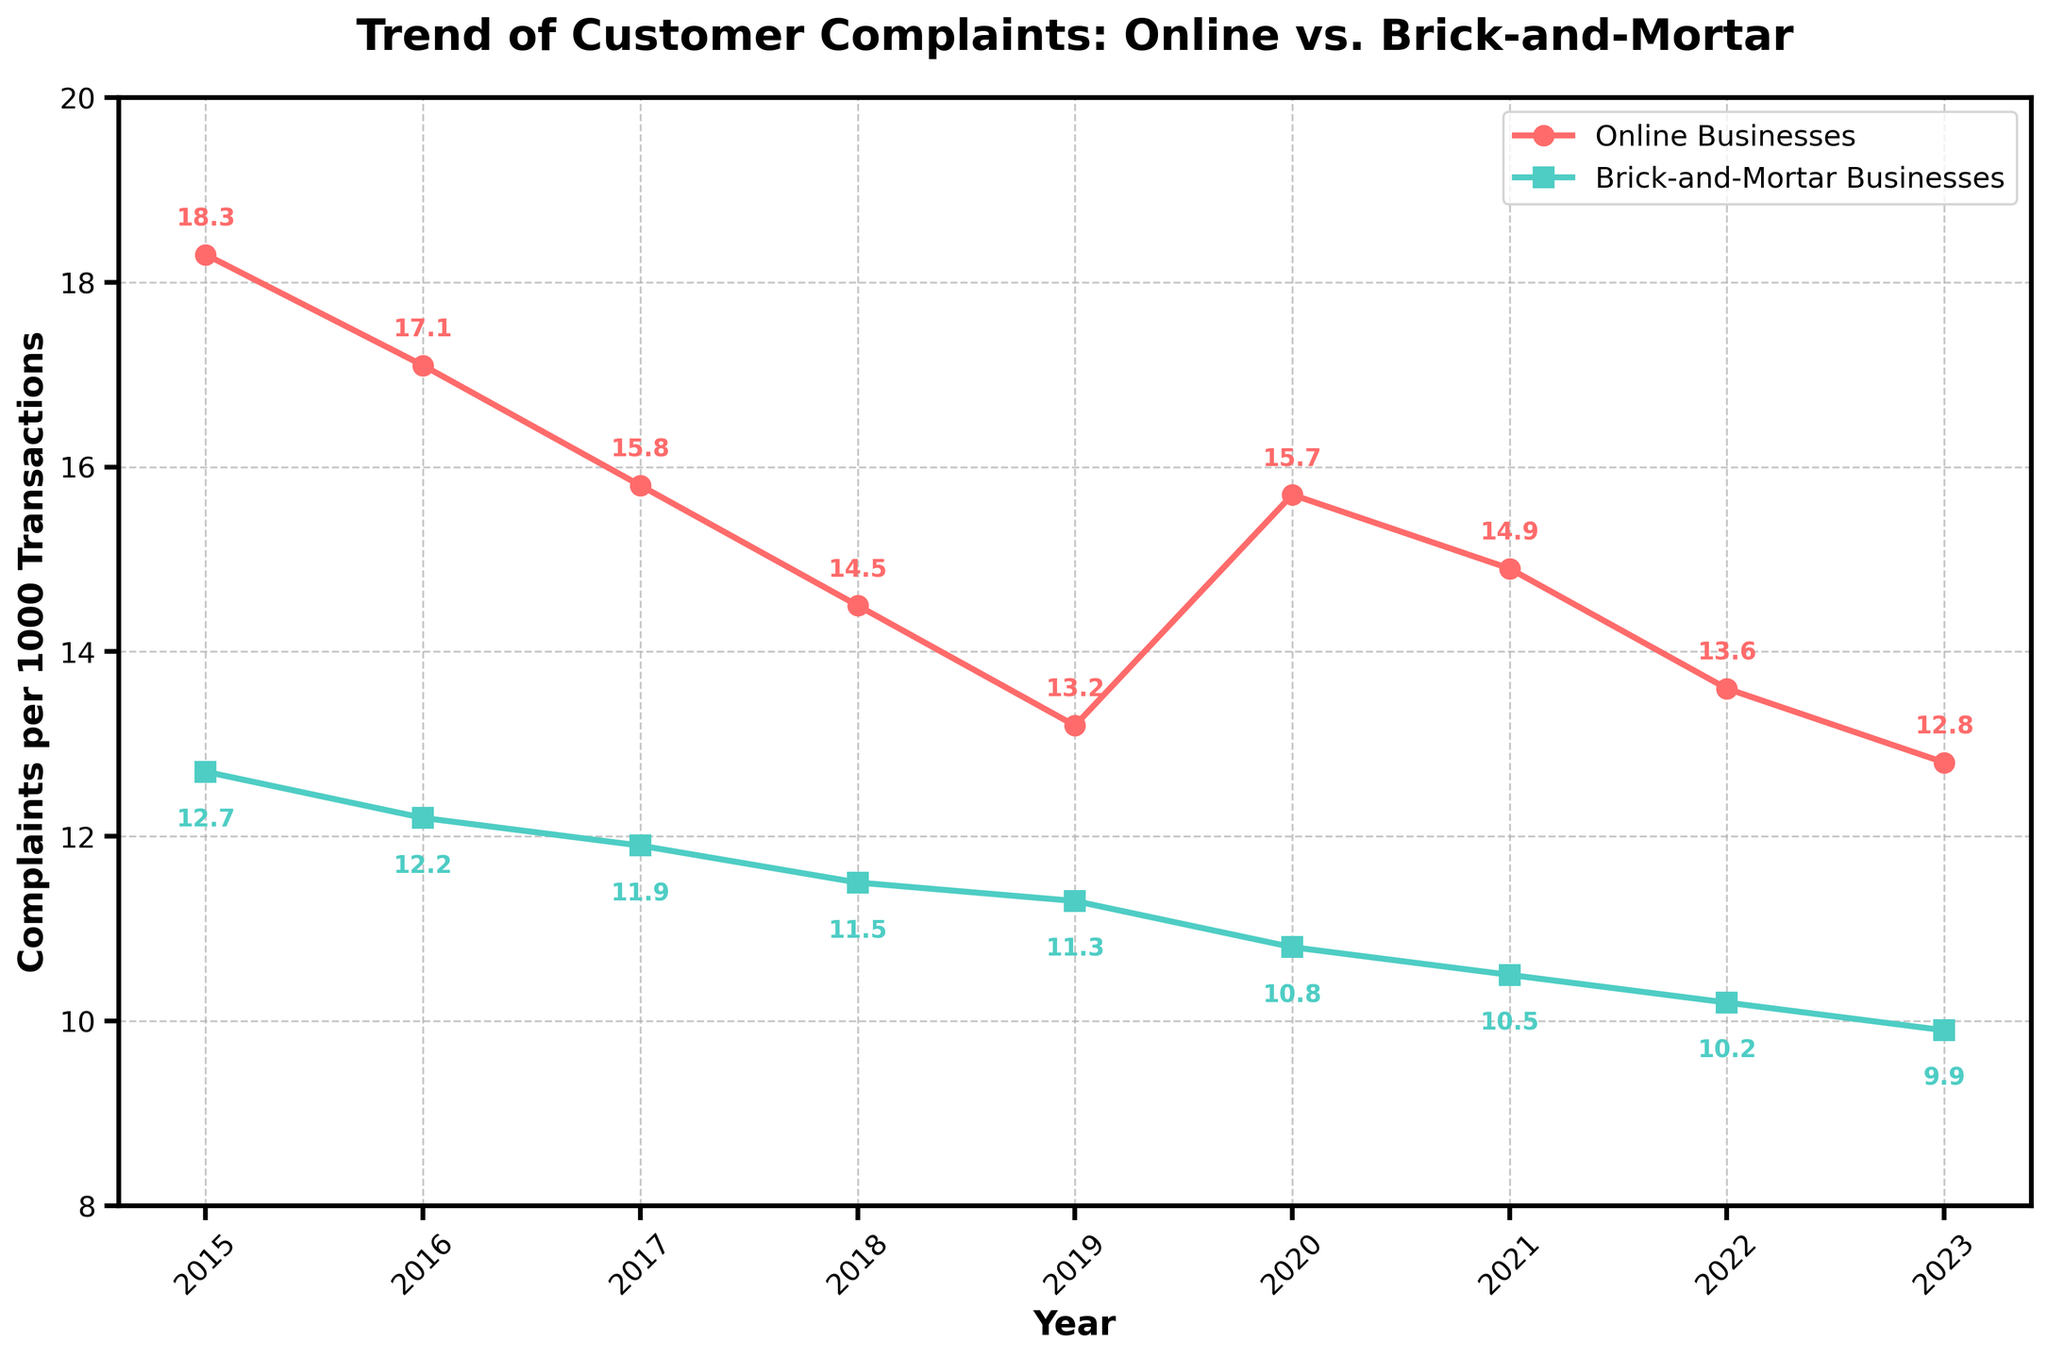What's the general trend of customer complaints for both online and brick-and-mortar businesses from 2015 to 2023? Both online and brick-and-mortar businesses show a general decline in customer complaints per 1000 transactions from 2015 to 2023. For online businesses, the complaints drop from 18.3 in 2015 to 12.8 in 2023. For brick-and-mortar businesses, the complaints decrease from 12.7 in 2015 to 9.9 in 2023.
Answer: Decline What marked change occurred in the complaint rates for online businesses between 2019 and 2020? Observation shows that the complaint rate for online businesses increased from 13.2 in 2019 to 15.7 in 2020, a jump of 2.5 complaints per 1000 transactions.
Answer: Increase of 2.5 Which year shows the highest customer complaint rate for brick-and-mortar businesses, and what is the value? The visually highest data point on the line for brick-and-mortar businesses occurs in 2015, with a complaint rate of 12.7 per 1000 transactions.
Answer: 2015, 12.7 complaints per 1000 transactions Between 2016 and 2017, which type of business (online or brick-and-mortar) showed a steeper decline in customer complaint rates? For online businesses, the complaint rate declined from 17.1 to 15.8, a decrease of 1.3. For brick-and-mortar businesses, the decline was from 12.2 to 11.9, a decrease of 0.3. The steeper decline was for online businesses (1.3).
Answer: Online businesses On average, how many complaints per 1000 transactions did online businesses receive from 2015 to 2023? To find the average, sum the values from each year and then divide by the number of years. 
(18.3 + 17.1 + 15.8 + 14.5 + 13.2 + 15.7 + 14.9 + 13.6 + 12.8) / 9 ≈ 15.5
Answer: 15.5 Compare the rates in customer complaints between online and brick-and-mortar businesses in 2021. Which has fewer complaints, and by how much? In 2021, online businesses had 14.9 complaints per 1000 transactions while brick-and-mortar businesses had 10.5. The difference is 14.9 - 10.5 = 4.4, with brick-and-mortar businesses having fewer complaints.
Answer: Brick-and-mortar businesses by 4.4 